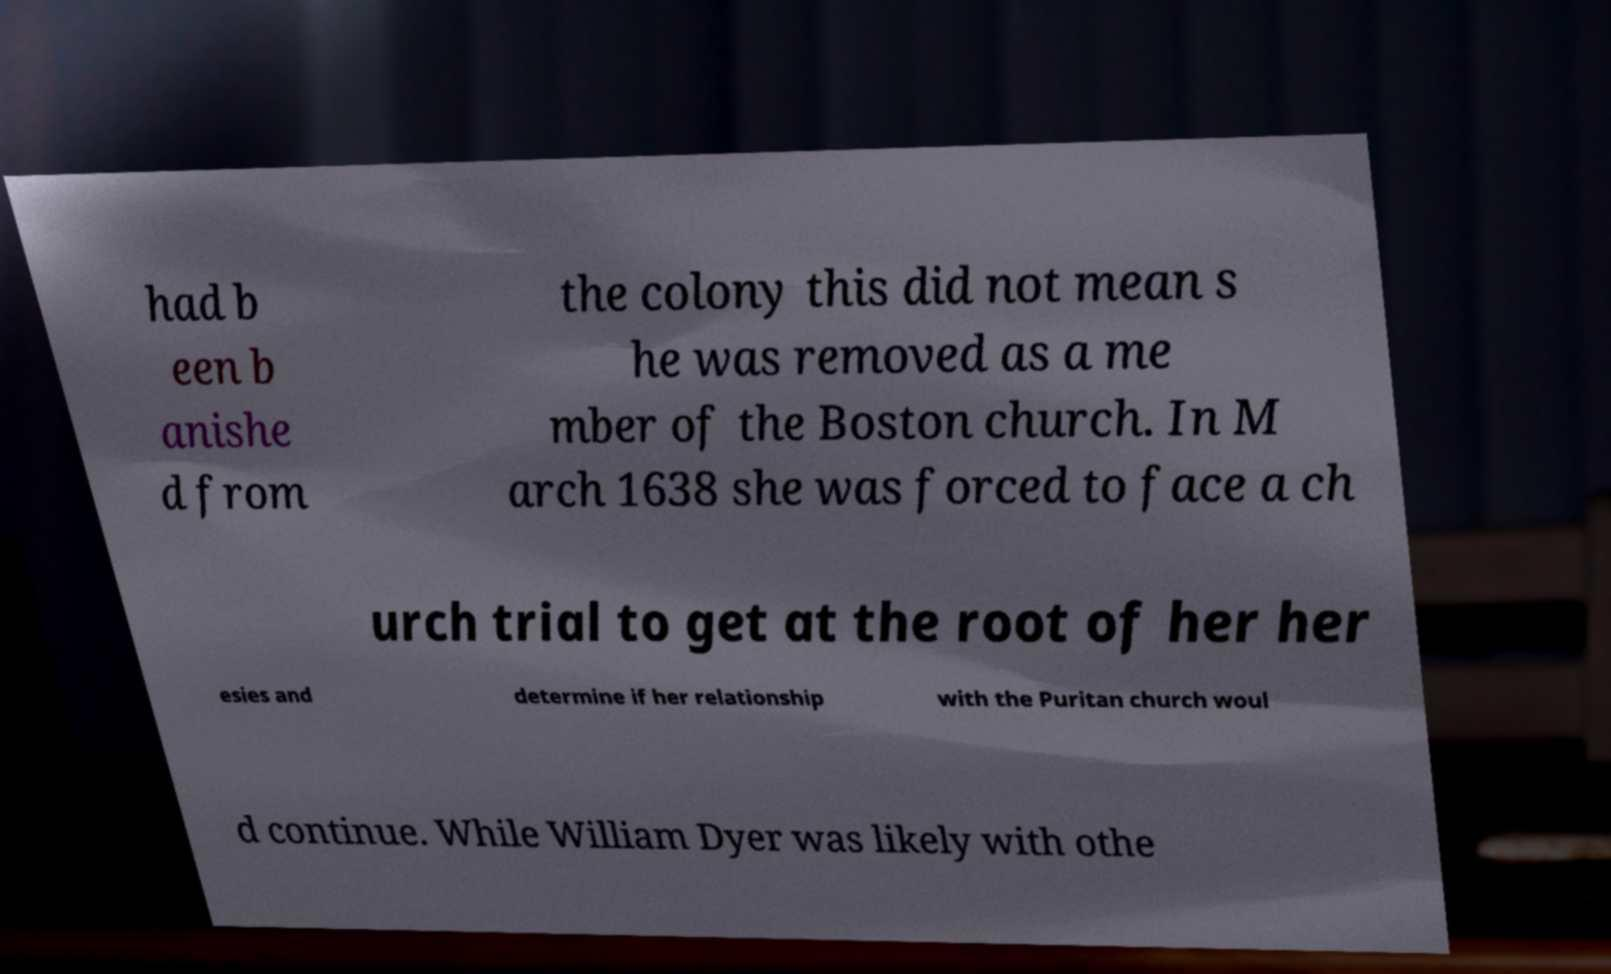What messages or text are displayed in this image? I need them in a readable, typed format. had b een b anishe d from the colony this did not mean s he was removed as a me mber of the Boston church. In M arch 1638 she was forced to face a ch urch trial to get at the root of her her esies and determine if her relationship with the Puritan church woul d continue. While William Dyer was likely with othe 